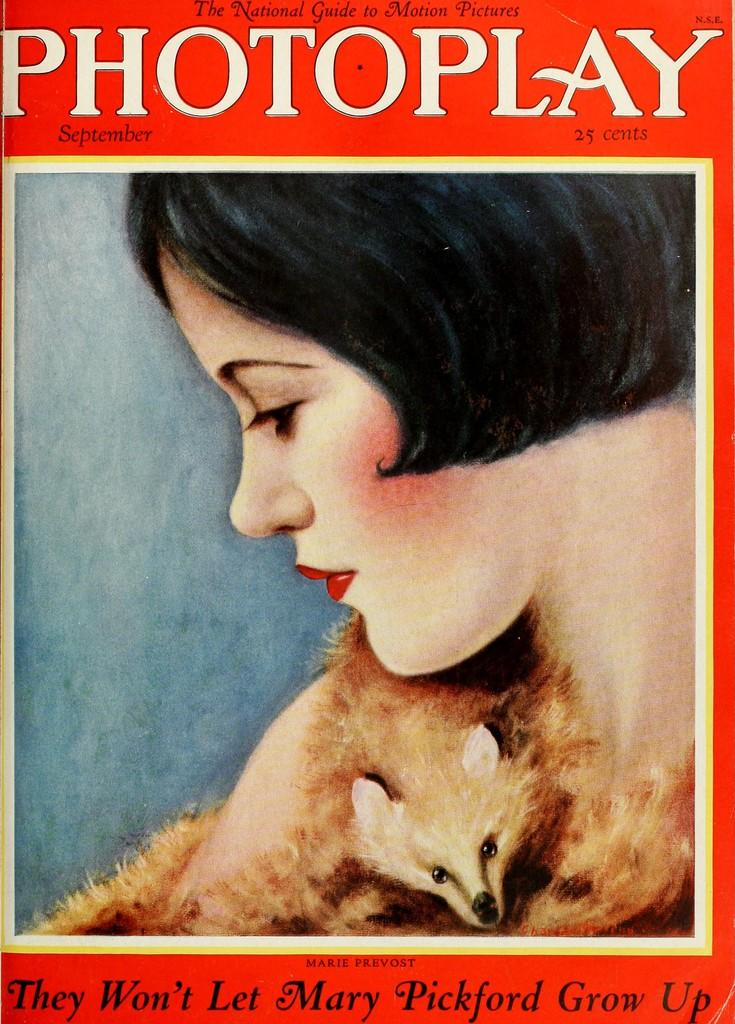What is depicted in the image alongside the woman? There is a depiction of an animal in the image. Can you describe the text that is written on the image? There is text written on the top and bottom of the image. What is the subject matter of the image? The image depicts a woman and an animal. How many bells are hanging from the branch in the image? There is no branch or bells present in the image. 